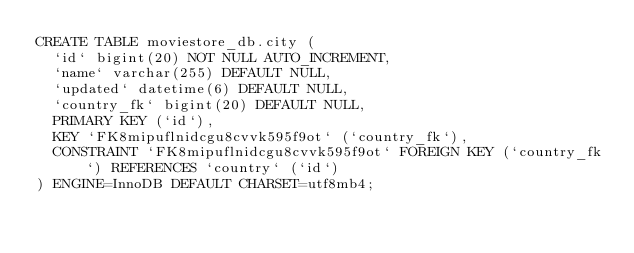<code> <loc_0><loc_0><loc_500><loc_500><_SQL_>CREATE TABLE moviestore_db.city (
  `id` bigint(20) NOT NULL AUTO_INCREMENT,
  `name` varchar(255) DEFAULT NULL,
  `updated` datetime(6) DEFAULT NULL,
  `country_fk` bigint(20) DEFAULT NULL,
  PRIMARY KEY (`id`),
  KEY `FK8mipuflnidcgu8cvvk595f9ot` (`country_fk`),
  CONSTRAINT `FK8mipuflnidcgu8cvvk595f9ot` FOREIGN KEY (`country_fk`) REFERENCES `country` (`id`)
) ENGINE=InnoDB DEFAULT CHARSET=utf8mb4;
</code> 